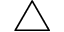Convert formula to latex. <formula><loc_0><loc_0><loc_500><loc_500>\triangle</formula> 